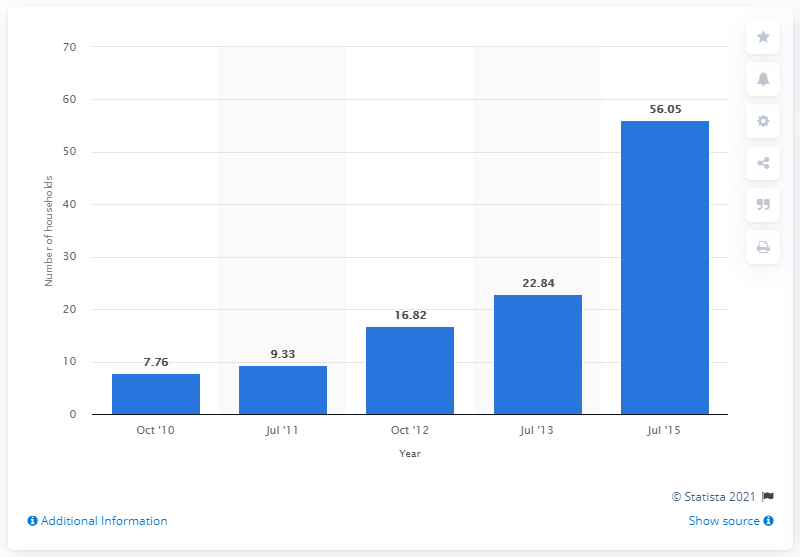Outline some significant characteristics in this image. In July 2015, approximately 56.05% of households in the United States had mobile internet access. 